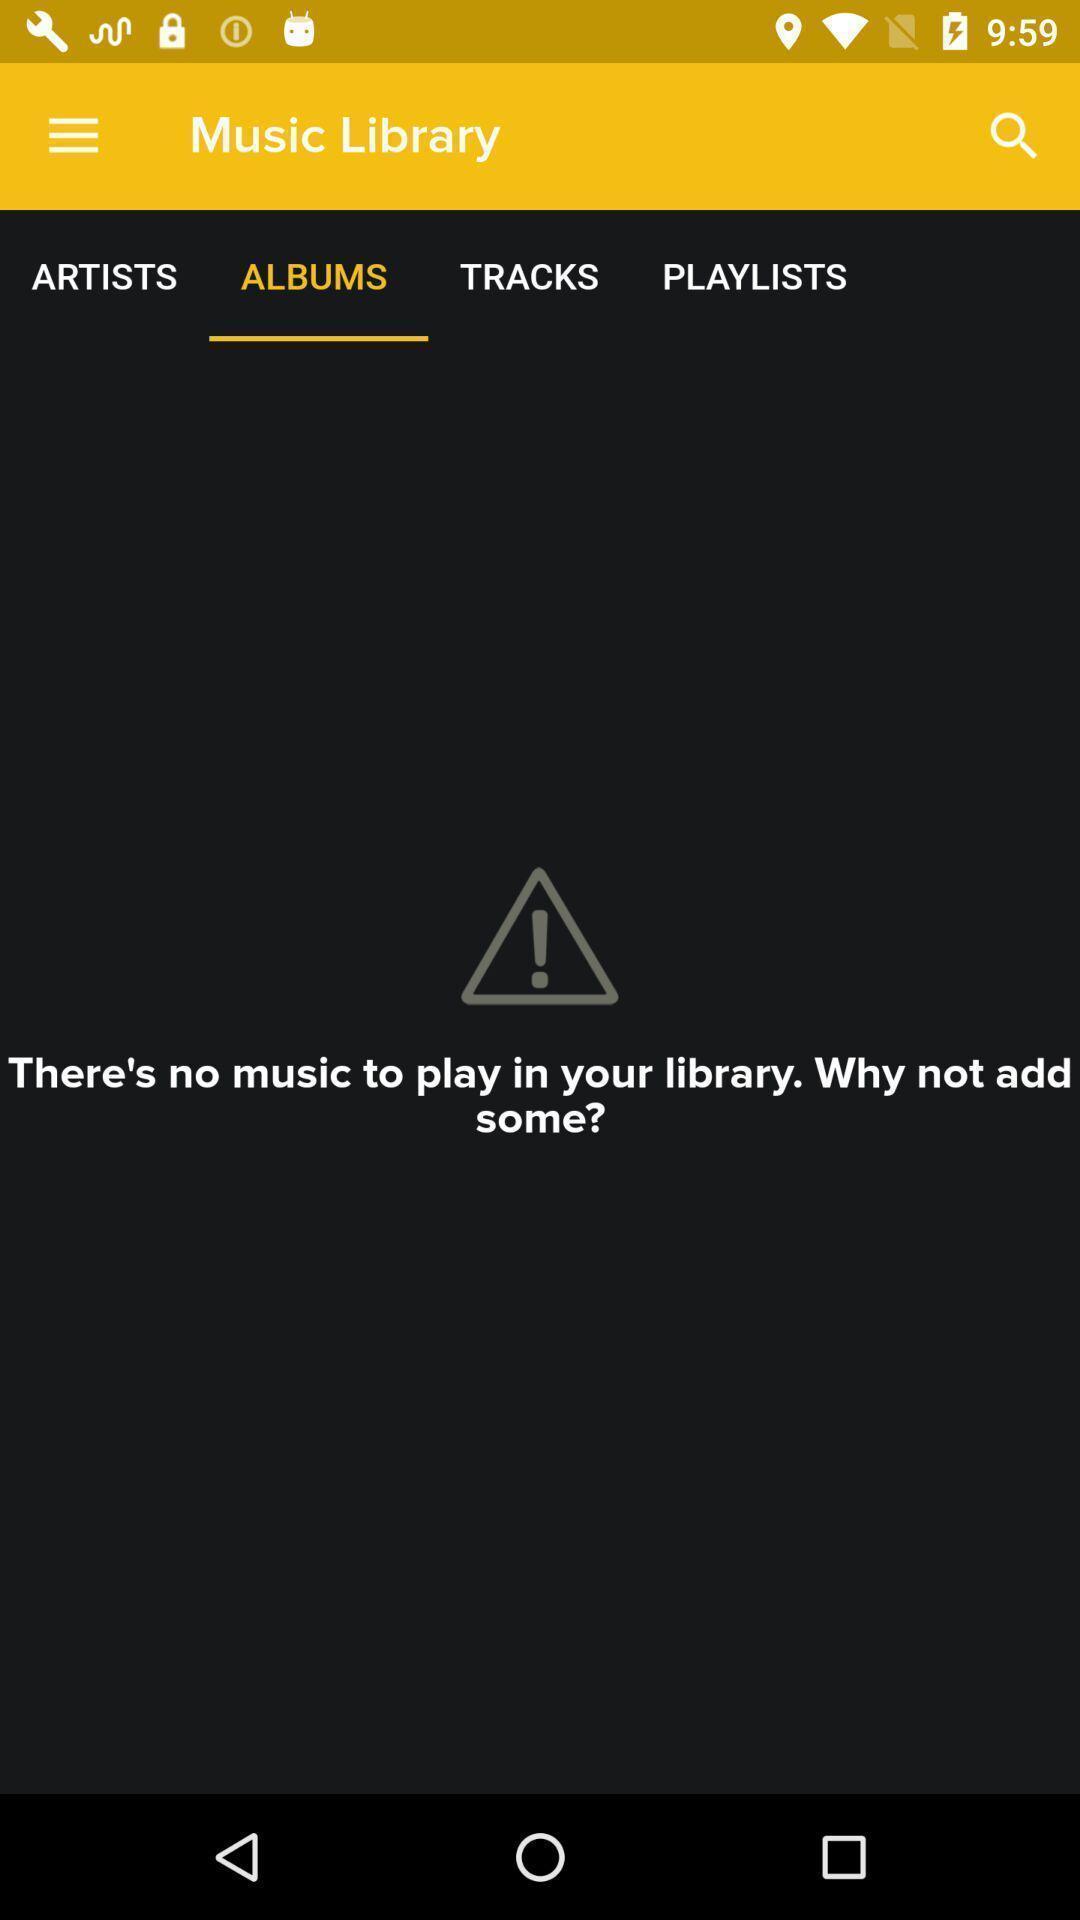Provide a description of this screenshot. Screen displaying contents in albums page of a music application. 